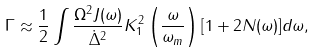Convert formula to latex. <formula><loc_0><loc_0><loc_500><loc_500>\Gamma \approx \frac { 1 } { 2 } \int \frac { \Omega ^ { 2 } J ( \omega ) } { \dot { \Delta } ^ { 2 } } K _ { 1 } ^ { 2 } \left ( \frac { \omega } { \omega _ { m } } \right ) [ 1 + 2 N ( \omega ) ] d \omega ,</formula> 